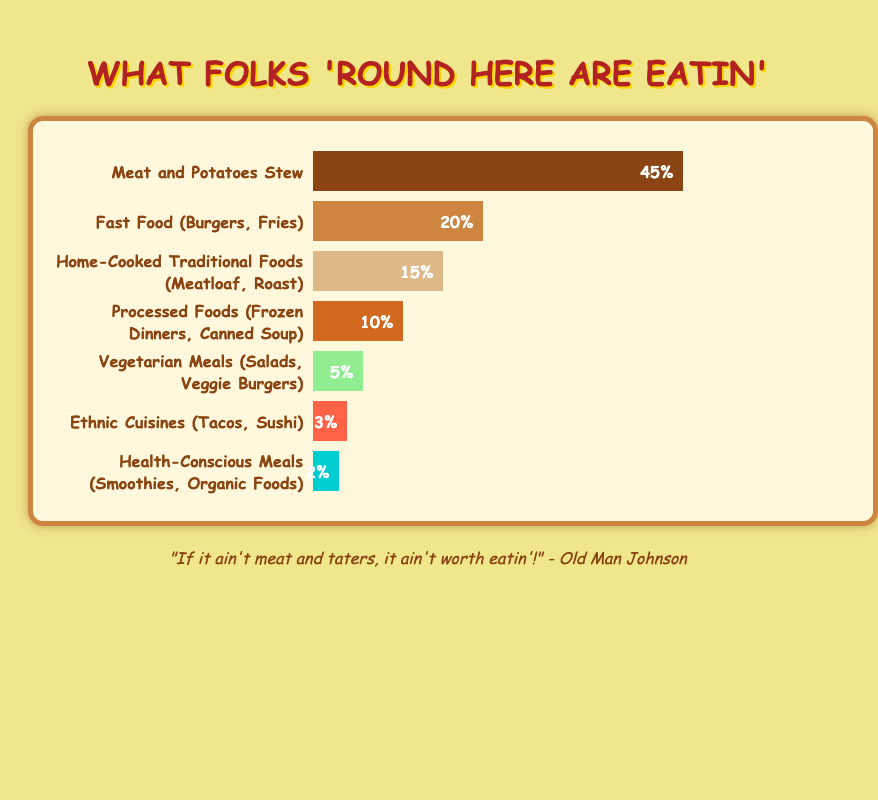Which food category has the highest percentage in the dietary preferences? By looking at the widths of the bars, the "Meat and Potatoes Stew" has the longest bar, representing the highest percentage.
Answer: Meat and Potatoes Stew What is the combined percentage of "Fast Food (Burgers, Fries)" and "Home-Cooked Traditional Foods (Meatloaf, Roast)"? The percentages for these categories are 20% and 15% respectively. Adding them together gives 20% + 15% = 35%.
Answer: 35% Which food category has a smaller percentage than "Processed Foods (Frozen Dinners, Canned Soup)" but larger than "Health-Conscious Meals (Smoothies, Organic Foods)"? "Processed Foods (Frozen Dinners, Canned Soup)" is 10% and "Health-Conscious Meals (Smoothies, Organic Foods)" is 2%. The category between them is "Vegetarian Meals (Salads, Veggie Burgers)" with 5%.
Answer: Vegetarian Meals (Salads, Veggie Burgers) How much more popular is "Meat and Potatoes Stew" compared to "Ethnic Cuisines (Tacos, Sushi)"? "Meat and Potatoes Stew" is 45%, and "Ethnic Cuisines (Tacos, Sushi)" is 3%. Subtracting them gives 45% - 3% = 42%.
Answer: 42% What percentage of the dietary preferences is made up by the three least popular categories? The three least popular categories are "Vegetarian Meals (Salads, Veggie Burgers)" at 5%, "Ethnic Cuisines (Tacos, Sushi)" at 3%, and "Health-Conscious Meals (Smoothies, Organic Foods)" at 2%. Adding them gives 5% + 3% + 2% = 10%.
Answer: 10% Does "Fast Food (Burgers, Fries)" have a larger or smaller percentage than "Home-Cooked Traditional Foods (Meatloaf, Roast)"? "Fast Food (Burgers, Fries)" is at 20%, and "Home-Cooked Traditional Foods (Meatloaf, Roast)" is at 15%, making "Fast Food" larger.
Answer: Larger Which categories collectively make up more than half of the dietary preferences? The combined categories need to total over 50%. "Meat and Potatoes Stew" (45%) and "Fast Food (Burgers, Fries)" (20%) add up to 65%, which is more than half.
Answer: Meat and Potatoes Stew and Fast Food (Burgers, Fries) 